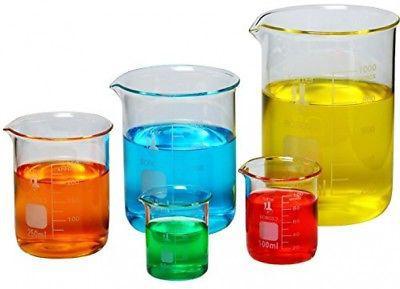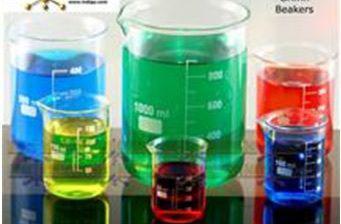The first image is the image on the left, the second image is the image on the right. Given the left and right images, does the statement "There are at least 11 beakers with there pourer facing left." hold true? Answer yes or no. Yes. The first image is the image on the left, the second image is the image on the right. For the images displayed, is the sentence "One image features exactly five beakers of different liquid colors, in the same shape but different sizes." factually correct? Answer yes or no. Yes. 